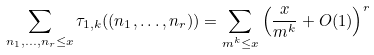Convert formula to latex. <formula><loc_0><loc_0><loc_500><loc_500>\sum _ { n _ { 1 } , \dots , n _ { r } \leq x } \tau _ { 1 , k } ( ( n _ { 1 } , \dots , n _ { r } ) ) = \sum _ { m ^ { k } \leq x } \left ( \frac { x } { m ^ { k } } + O ( 1 ) \right ) ^ { r }</formula> 